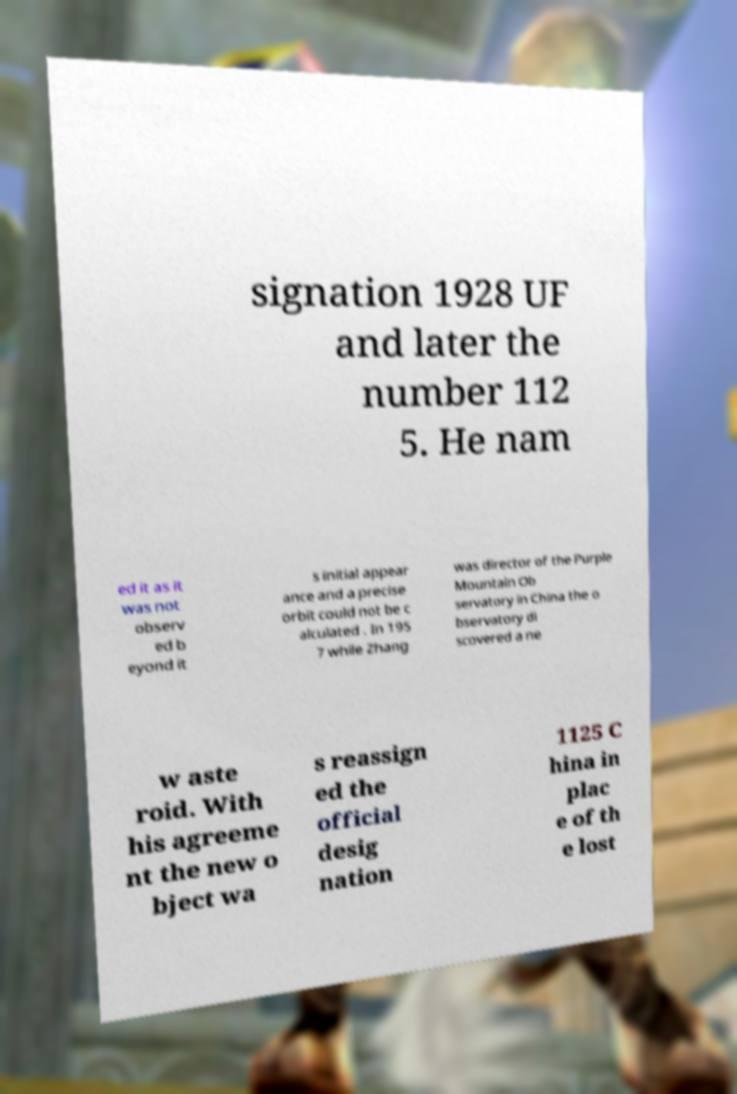I need the written content from this picture converted into text. Can you do that? signation 1928 UF and later the number 112 5. He nam ed it as it was not observ ed b eyond it s initial appear ance and a precise orbit could not be c alculated . In 195 7 while Zhang was director of the Purple Mountain Ob servatory in China the o bservatory di scovered a ne w aste roid. With his agreeme nt the new o bject wa s reassign ed the official desig nation 1125 C hina in plac e of th e lost 